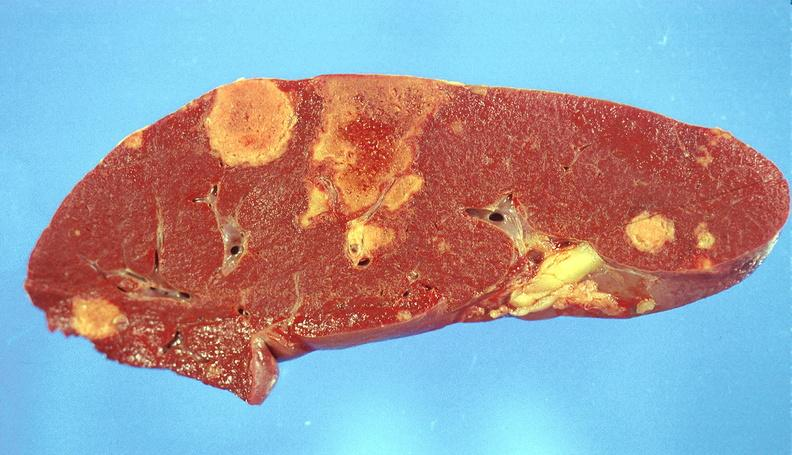what is present?
Answer the question using a single word or phrase. Hematologic 